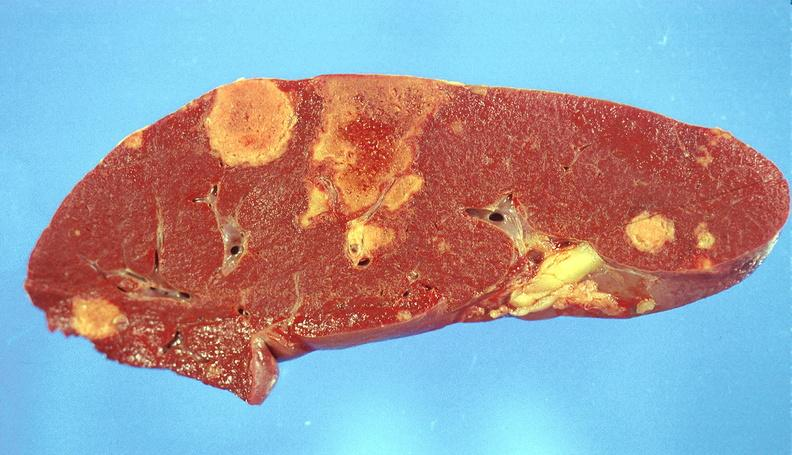what is present?
Answer the question using a single word or phrase. Hematologic 